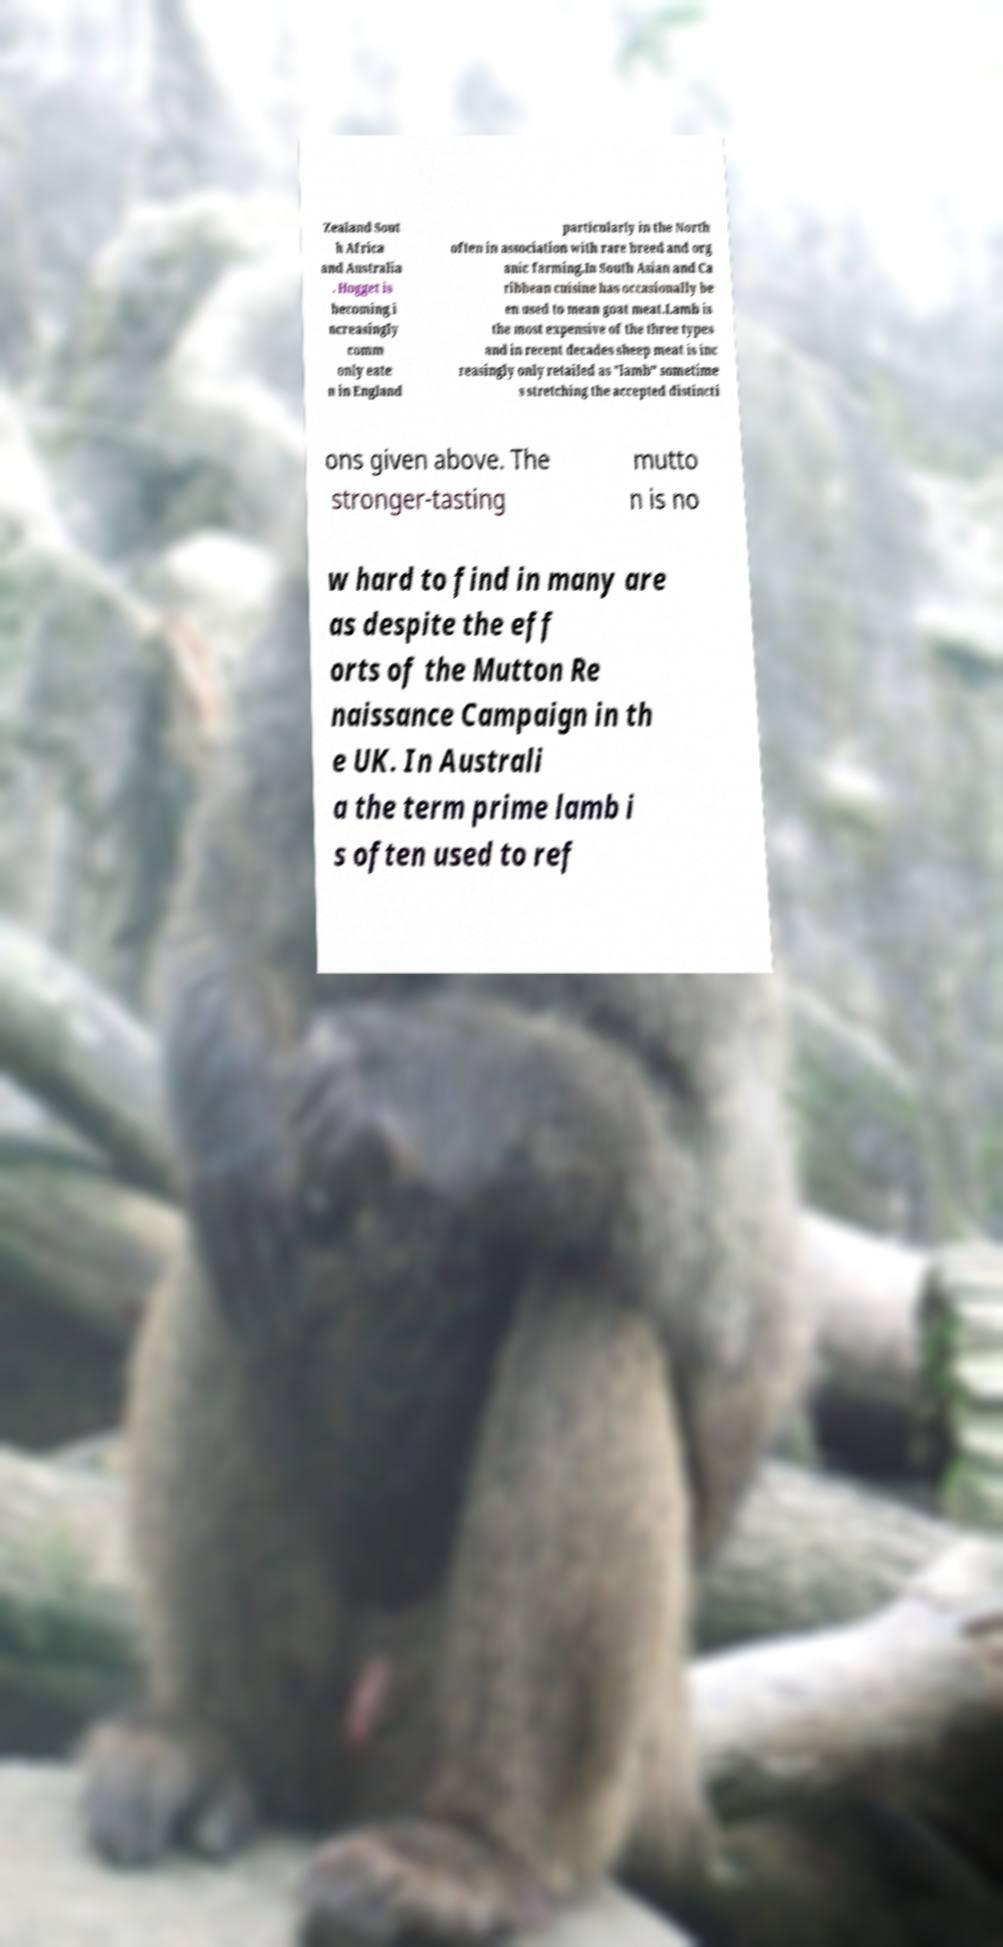Please read and relay the text visible in this image. What does it say? Zealand Sout h Africa and Australia . Hogget is becoming i ncreasingly comm only eate n in England particularly in the North often in association with rare breed and org anic farming.In South Asian and Ca ribbean cuisine has occasionally be en used to mean goat meat.Lamb is the most expensive of the three types and in recent decades sheep meat is inc reasingly only retailed as "lamb" sometime s stretching the accepted distincti ons given above. The stronger-tasting mutto n is no w hard to find in many are as despite the eff orts of the Mutton Re naissance Campaign in th e UK. In Australi a the term prime lamb i s often used to ref 